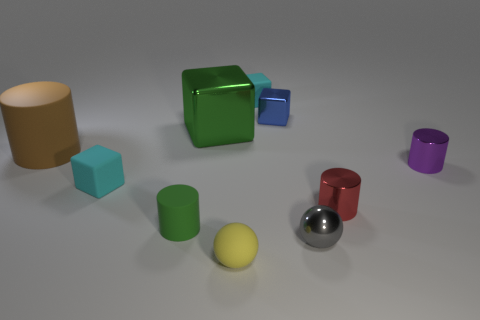Subtract all green blocks. How many blocks are left? 3 Subtract all gray spheres. How many cyan blocks are left? 2 Subtract all purple cylinders. How many cylinders are left? 3 Subtract 1 blocks. How many blocks are left? 3 Subtract all blocks. How many objects are left? 6 Add 4 metal blocks. How many metal blocks exist? 6 Subtract 1 blue blocks. How many objects are left? 9 Subtract all yellow blocks. Subtract all yellow cylinders. How many blocks are left? 4 Subtract all large gray matte cylinders. Subtract all tiny rubber cylinders. How many objects are left? 9 Add 6 green cylinders. How many green cylinders are left? 7 